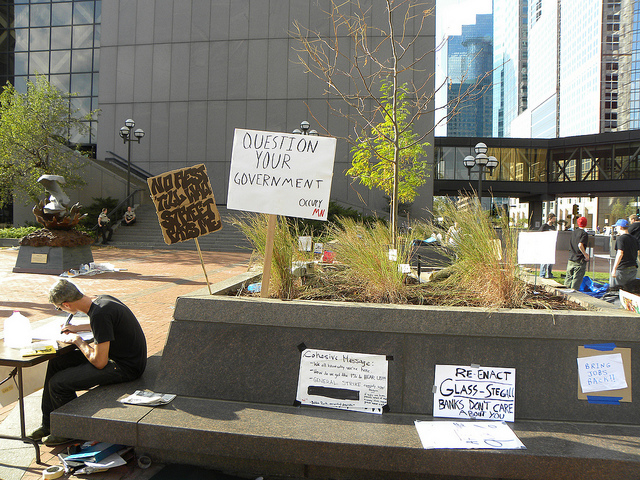Can you describe the overall atmosphere of the scene depicted in the image? The scene appears to be a calm and perhaps contemplative environment typical of a peaceful protest. The presence of handwritten signs suggests grassroots activism, and the solitary man reading reinforces a quiet yet purposeful ambiance. The background reveals an urban setting, possibly a public square or park, which is a common venue for such gatherings. 